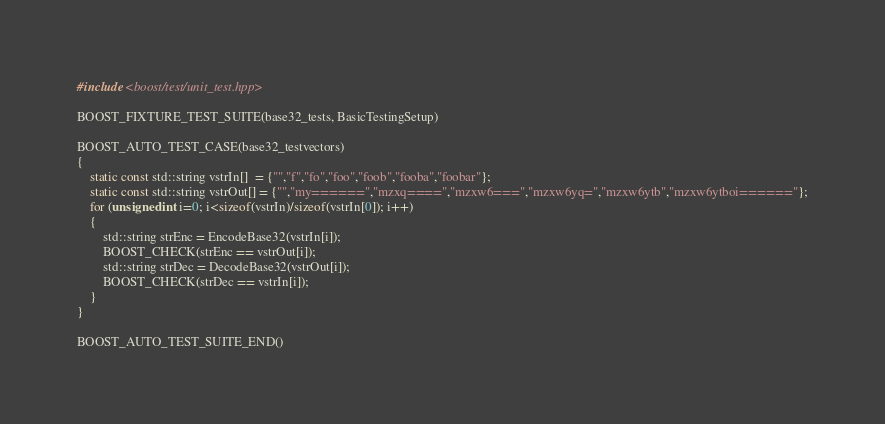<code> <loc_0><loc_0><loc_500><loc_500><_C++_>#include <boost/test/unit_test.hpp>

BOOST_FIXTURE_TEST_SUITE(base32_tests, BasicTestingSetup)

BOOST_AUTO_TEST_CASE(base32_testvectors)
{
    static const std::string vstrIn[]  = {"","f","fo","foo","foob","fooba","foobar"};
    static const std::string vstrOut[] = {"","my======","mzxq====","mzxw6===","mzxw6yq=","mzxw6ytb","mzxw6ytboi======"};
    for (unsigned int i=0; i<sizeof(vstrIn)/sizeof(vstrIn[0]); i++)
    {
        std::string strEnc = EncodeBase32(vstrIn[i]);
        BOOST_CHECK(strEnc == vstrOut[i]);
        std::string strDec = DecodeBase32(vstrOut[i]);
        BOOST_CHECK(strDec == vstrIn[i]);
    }
}

BOOST_AUTO_TEST_SUITE_END()
</code> 